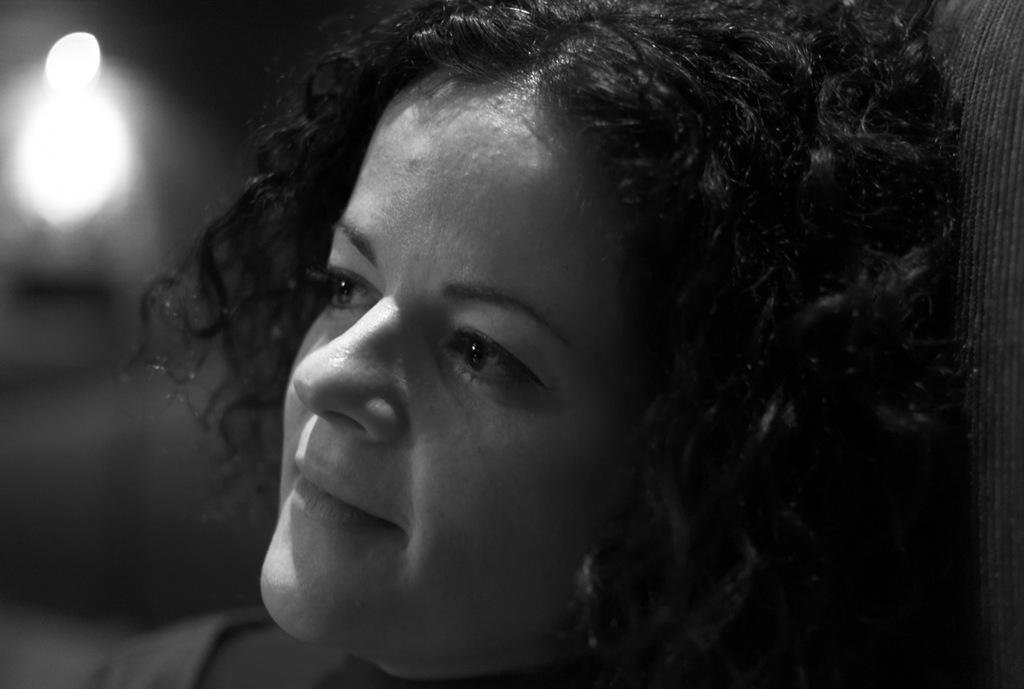What is the color scheme of the image? The image is black and white. What can be seen in the image? There is a person's face visible in the image. What event is depicted on the calendar in the image? There is no calendar present in the image, so it is not possible to determine what event might be depicted. 